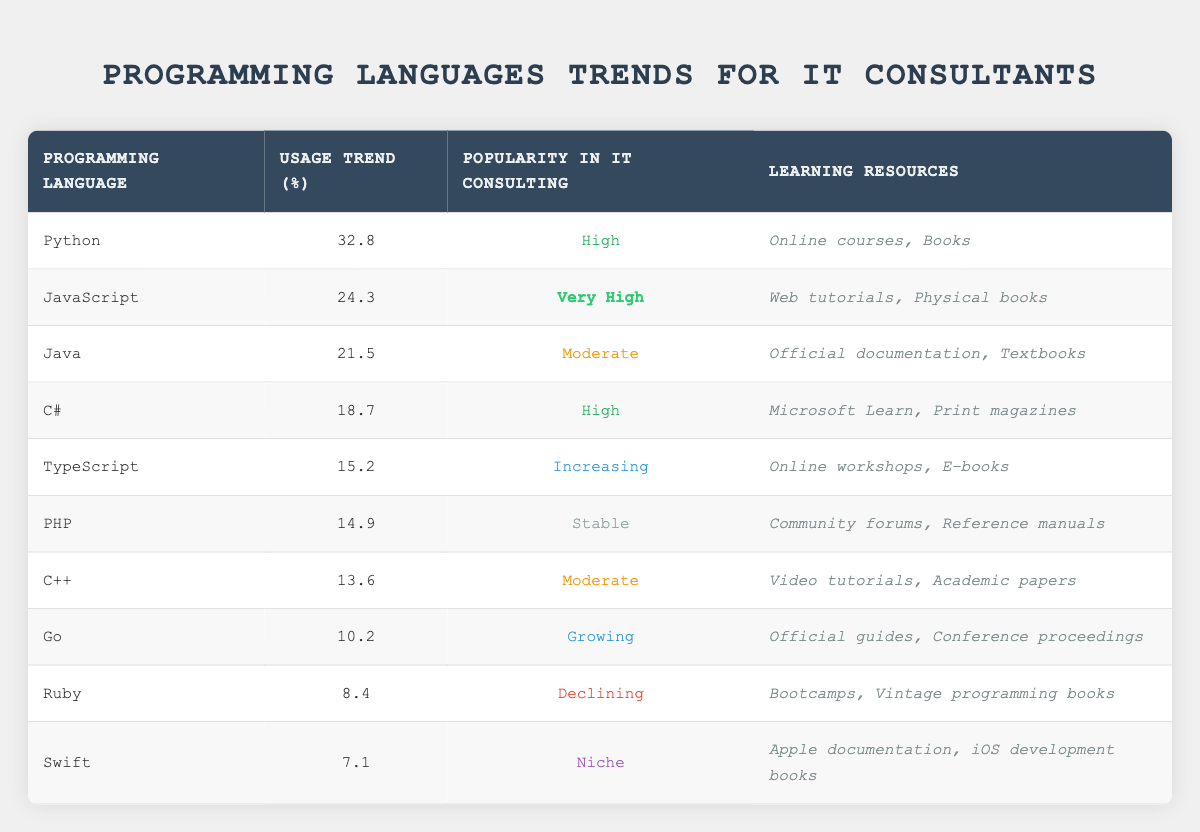What is the usage trend percentage for Python? The table shows that the usage trend percentage for Python is listed directly in the "Usage Trend (%)" column next to the "Python" row, which is 32.8.
Answer: 32.8 Which programming language has the highest popularity in IT consulting? Looking through the "Popularity in IT Consulting" column, JavaScript has the highest rating marked as "Very High."
Answer: JavaScript What is the average usage trend percentage of C#, TypeScript, and PHP? First, add the usage trends of these three languages: C# (18.7) + TypeScript (15.2) + PHP (14.9) = 48.8. Then, divide by 3 to find the average: 48.8 / 3 = 16.27.
Answer: 16.27 Is Ruby's popularity trend increasing? The "Popularity in IT Consulting" column indicates that Ruby is marked as "Declining," which means its trend is not increasing.
Answer: No What programming languages have a usage trend above 20%? By examining the "Usage Trend (%)" column, the languages with usage trends above 20% are Python (32.8), JavaScript (24.3), and Java (21.5).
Answer: Python, JavaScript, Java What is the difference in usage trend percentage between JavaScript and Swift? The usage trend for JavaScript is 24.3 and for Swift is 7.1. The difference is calculated as 24.3 - 7.1 = 17.2.
Answer: 17.2 Which two programming languages have "Moderate" popularity in IT consulting? The table shows two languages with a "Moderate" ranking: Java and C++.
Answer: Java, C++ How many programming languages are listed as having a "High" popularity in IT consulting? From the "Popularity in IT Consulting" column, C# and Python are identified as having "High" popularity. This gives a total of 2 languages.
Answer: 2 Which language has the lowest usage trend percentage? Scanning the "Usage Trend (%)" column, Swift has the lowest percentage listed at 7.1.
Answer: Swift 